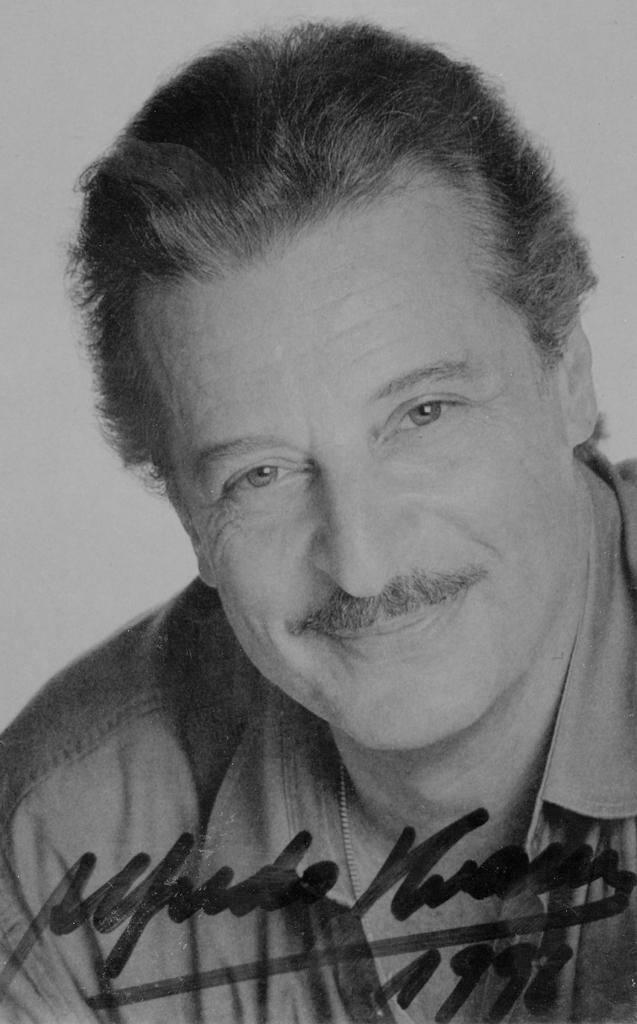What is the color scheme of the image? The image is black and white. Who is present in the image? There is a man in the image. What is the man doing in the image? The man is smiling. What is the woman wearing in the image? The woman is wearing a shirt. Can you describe any additional details in the image? There appears to be an autograph in the image. What type of chin can be seen on the church in the image? There is no church present in the image, so it is not possible to determine what type of chin might be seen on a church. 